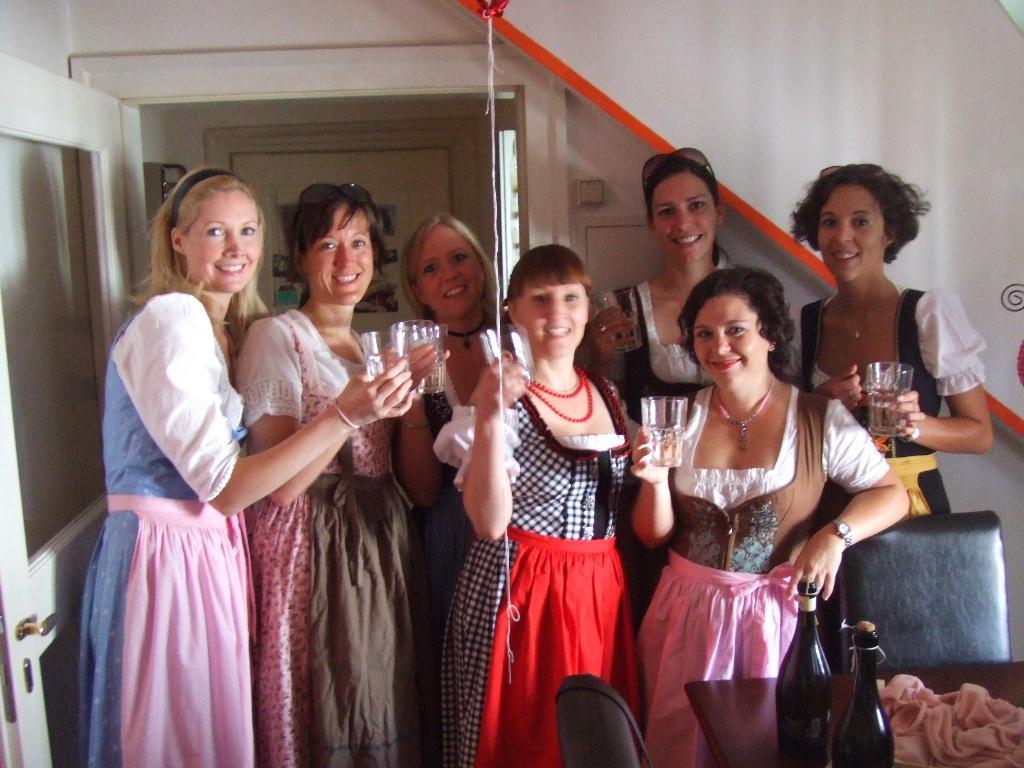Could you give a brief overview of what you see in this image? In this picture I can see a group of girls are standing by holding the glasses in their hands at the center. There are bottles on the right side, there is a door on the left side. 